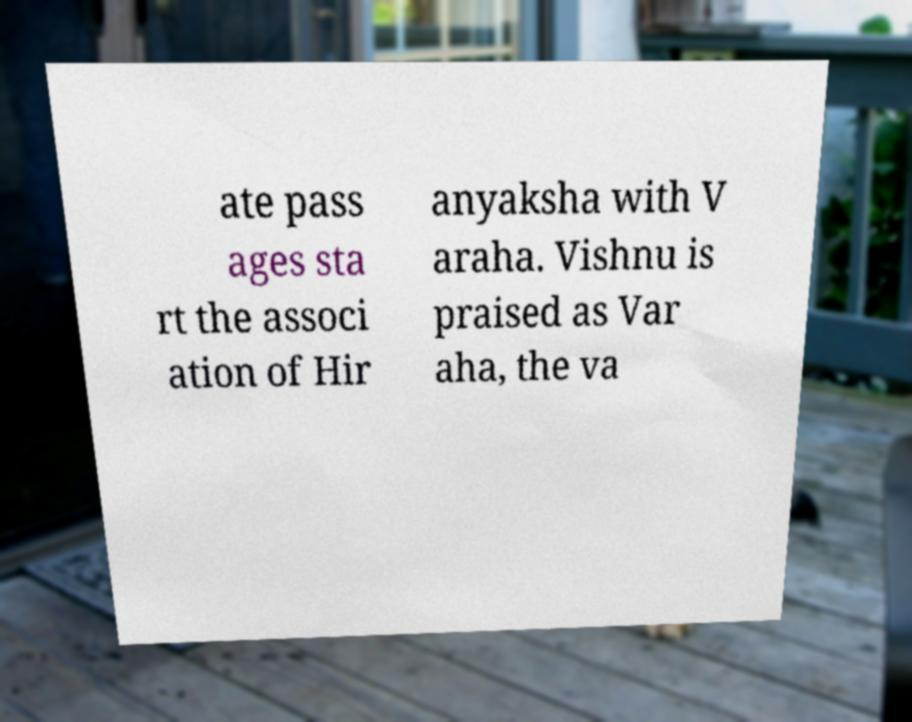Could you extract and type out the text from this image? ate pass ages sta rt the associ ation of Hir anyaksha with V araha. Vishnu is praised as Var aha, the va 